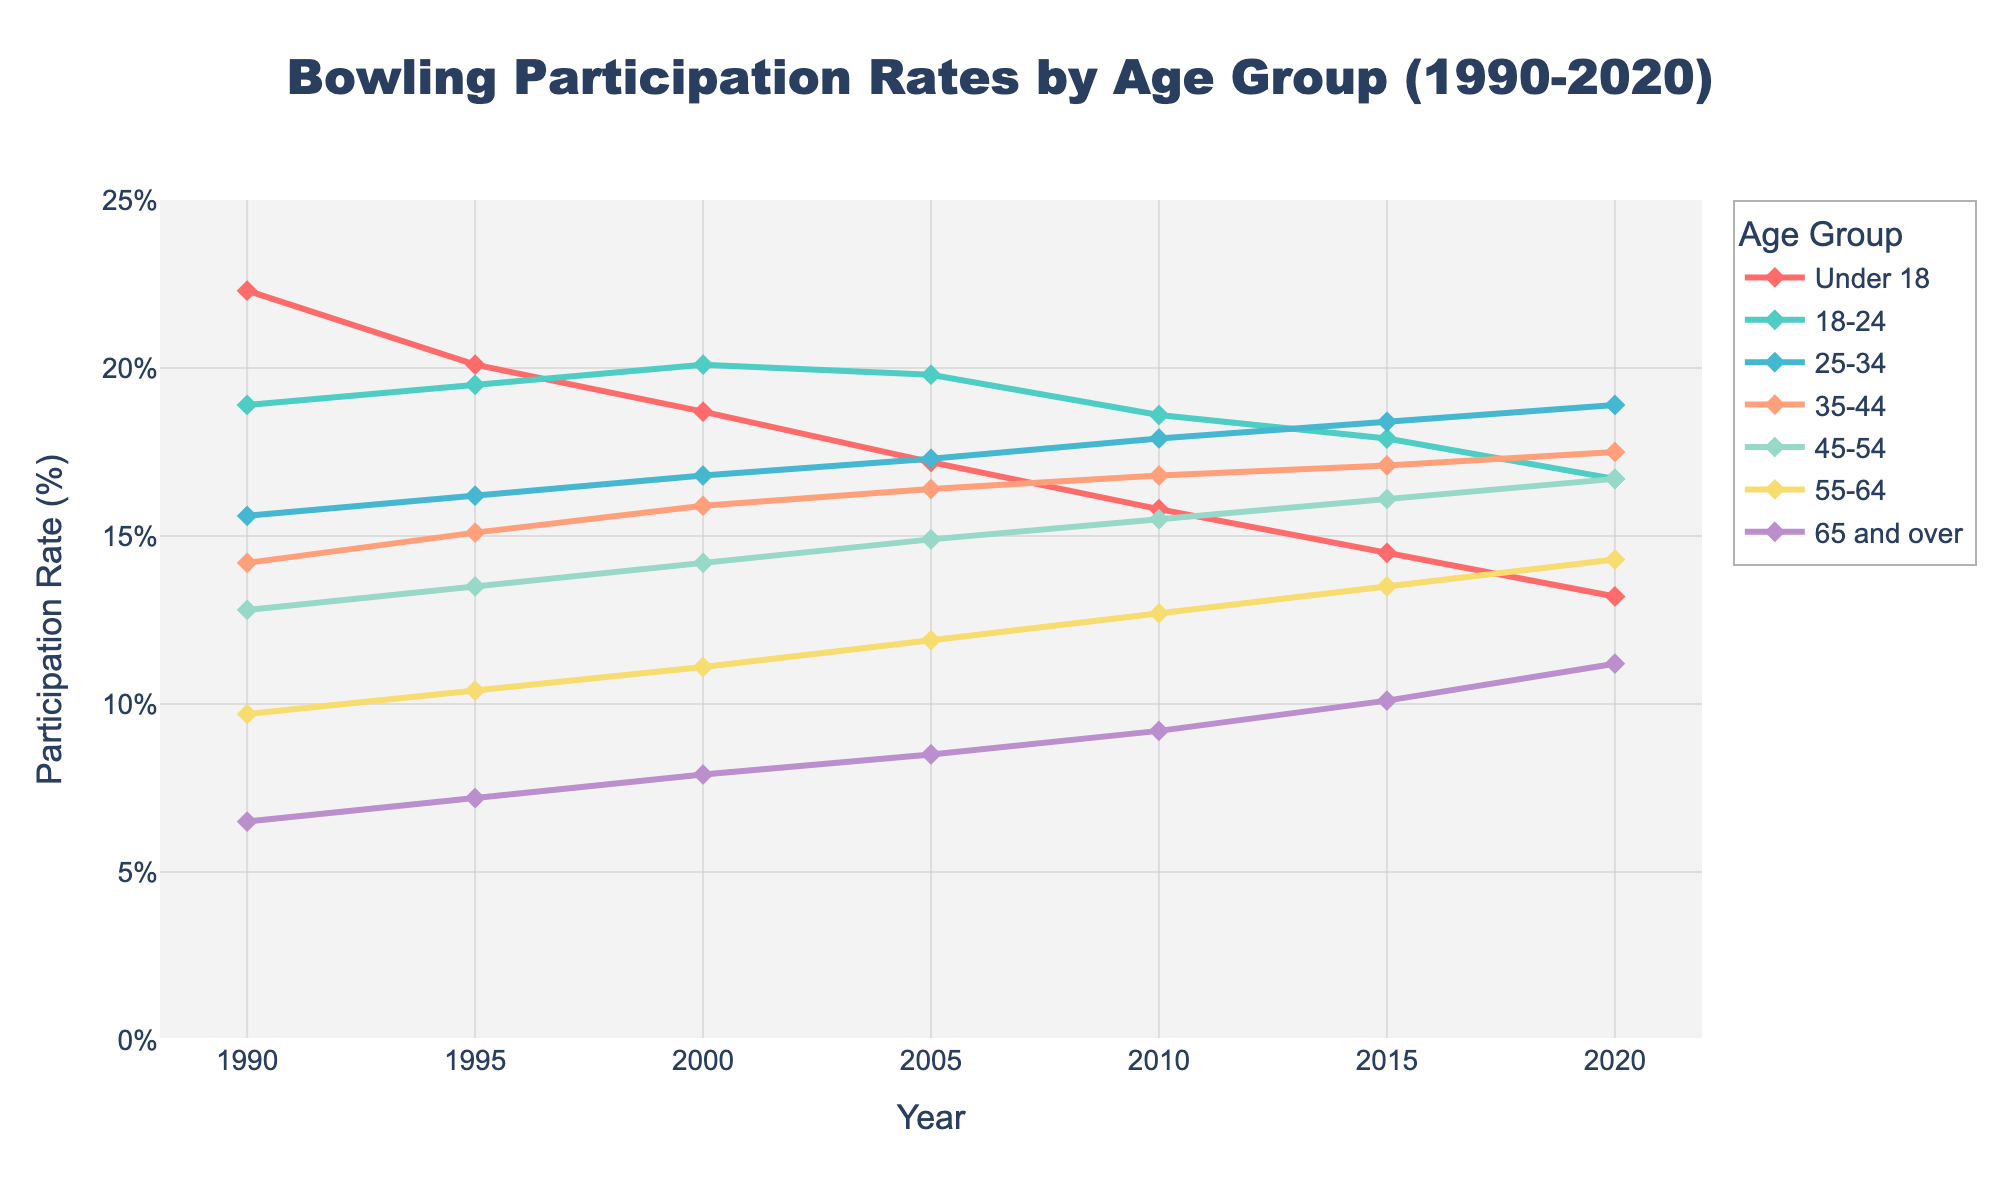What trend do we see for the participation rate of the 'Under 18' age group from 1990 to 2020? The data shows a consistent decrease in the participation rate for the 'Under 18' age group over the years from 22.3% in 1990 to 13.2% in 2020, indicating that fewer young people are bowling as time progresses.
Answer: Decrease Which age group has shown the most significant increase in participation rate from 1990 to 2020? By comparing the rates, '65 and over' age group increased from 6.5% in 1990 to 11.2% in 2020, which is the largest percentage increase among all age groups.
Answer: 65 and over How did the participation rate for the '25-34' age group change from 1995 to 2005? The '25-34' group's rate went from 16.2% in 1995 to 17.3% in 2005, showing an increase of 1.1%.
Answer: Increased by 1.1% Which age group had a consistent increase in participation rate every year from 1990 to 2020? By observing the lines, the '65 and over' age group shows a consistent increase each year without any decrease.
Answer: 65 and over What is the difference in participation rate between the '18-24' and '55-64' age groups in 2020? In 2020, the participation rate for '18-24' is 16.7%, and for '55-64' it is 14.3%. The difference is 16.7% - 14.3% = 2.4%.
Answer: 2.4% Which age group's participation rate surpassed another age group during the period of 1990 to 2020? The participation rate of the '55-64' age group surpassed the 'Under 18' age group during the period, particularly noticeable from the data trend lines.
Answer: 55-64 surpassed Under 18 Compare the visual line thickness and color for the '35-44' age group with the '45-54' age group. The line thickness of both age groups is the same, but the colors are different. '35-44' is represented by a distinct color compared to '45-54'.
Answer: Same thickness, different colors Which age group had the highest participation rate in 1990 and what was the value? By looking at the starting points of all lines, the 'Under 18' age group had the highest participation rate at 22.3% in 1990.
Answer: Under 18, 22.3% Which age group had the lowest participation rate in 2015, and what was that rate? By inspecting the data points for 2015, '65 and over' had the lowest participation rate at 10.1%.
Answer: 65 and over, 10.1% What is the average increase in participation rate for the '45-54' age group from 1990 to 2020? The participation rates are: (13.5-12.8), (14.2-13.5), (14.9-14.2), (15.5-14.9), (16.1-15.5), (16.7-16.1). The average increase is (0.7+0.7+0.7+0.6+0.6+0.6)/6 = 0.65% per period.
Answer: 0.65% 